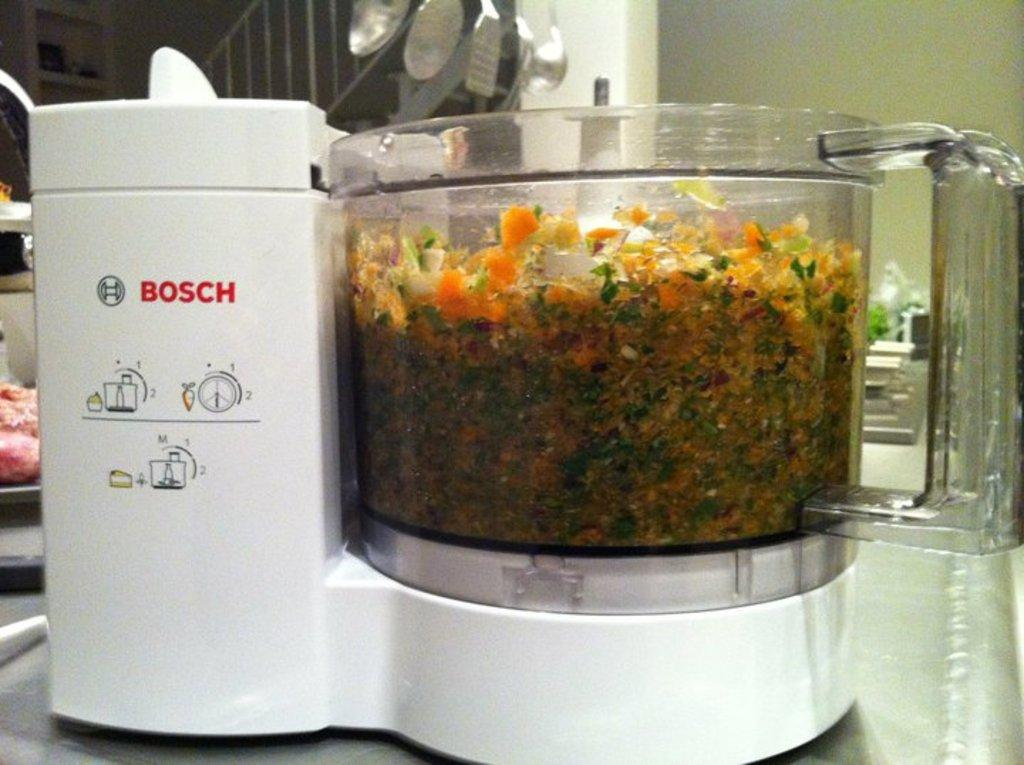<image>
Share a concise interpretation of the image provided. A large kitchen mixer full of vegetables showing steps 1 + 2 on the side. 